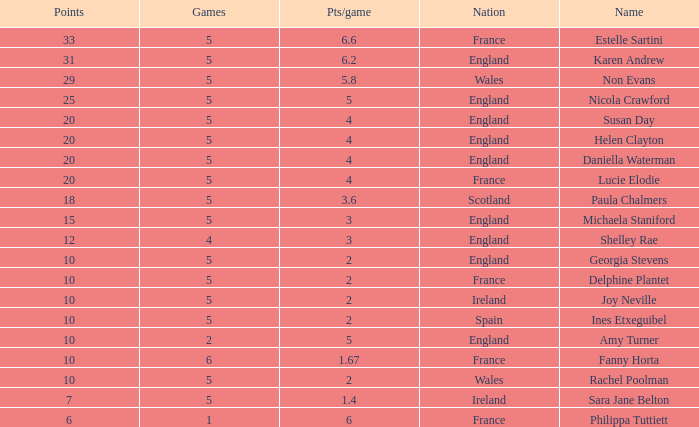Can you tell me the average Points that has a Pts/game larger than 4, and the Nation of england, and the Games smaller than 5? 10.0. 